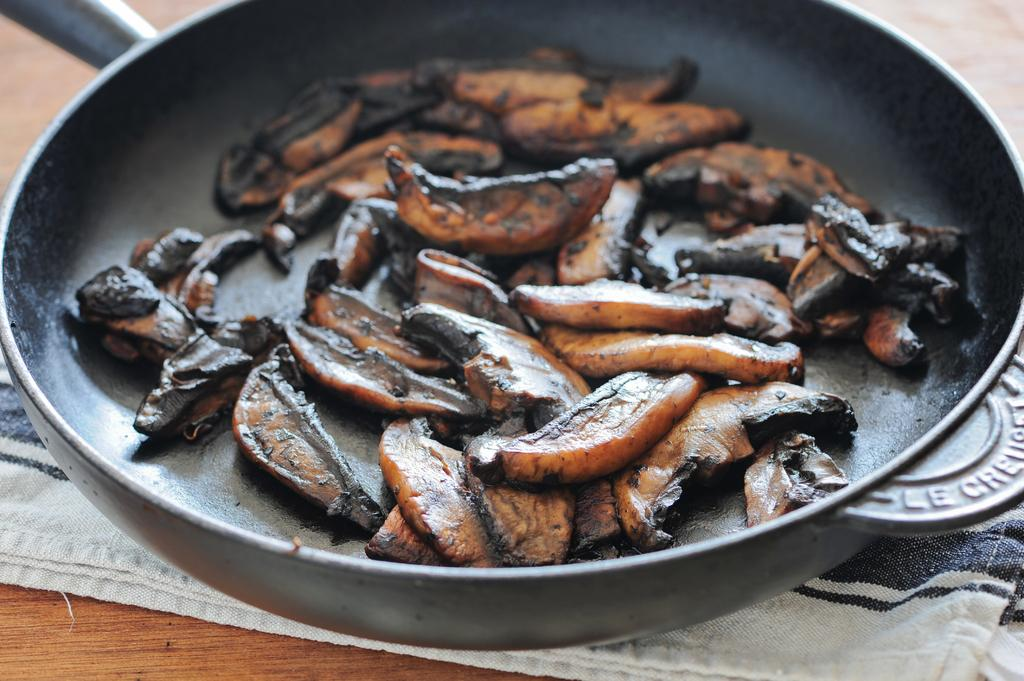What is present in the image related to food? There is food in the image. How is the food contained in the image? The food is in a black color vessel. What is the vessel placed on in the image? The vessel is on a cloth. What is the color of the surface beneath the cloth in the image? The surface beneath the cloth is brown color. Are there any berries visible in the image? There is no mention of berries in the provided facts, so it cannot be determined if they are present in the image. 